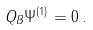<formula> <loc_0><loc_0><loc_500><loc_500>Q _ { B } \Psi ^ { ( 1 ) } = 0 \, .</formula> 